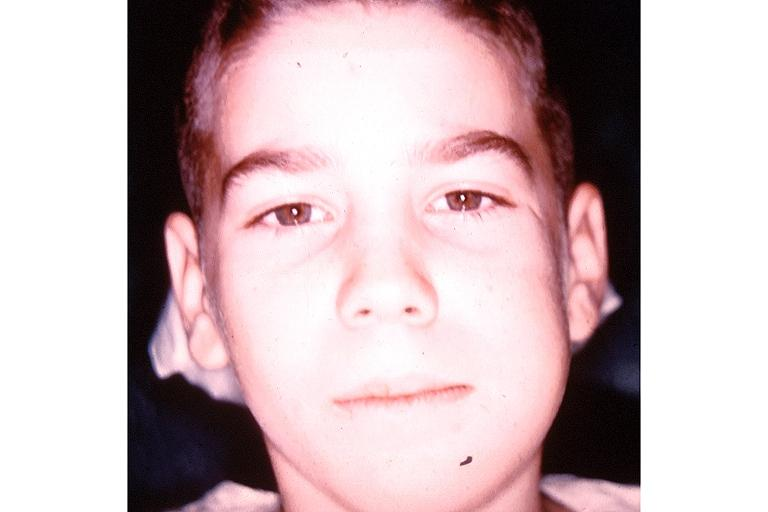where is this?
Answer the question using a single word or phrase. Oral 